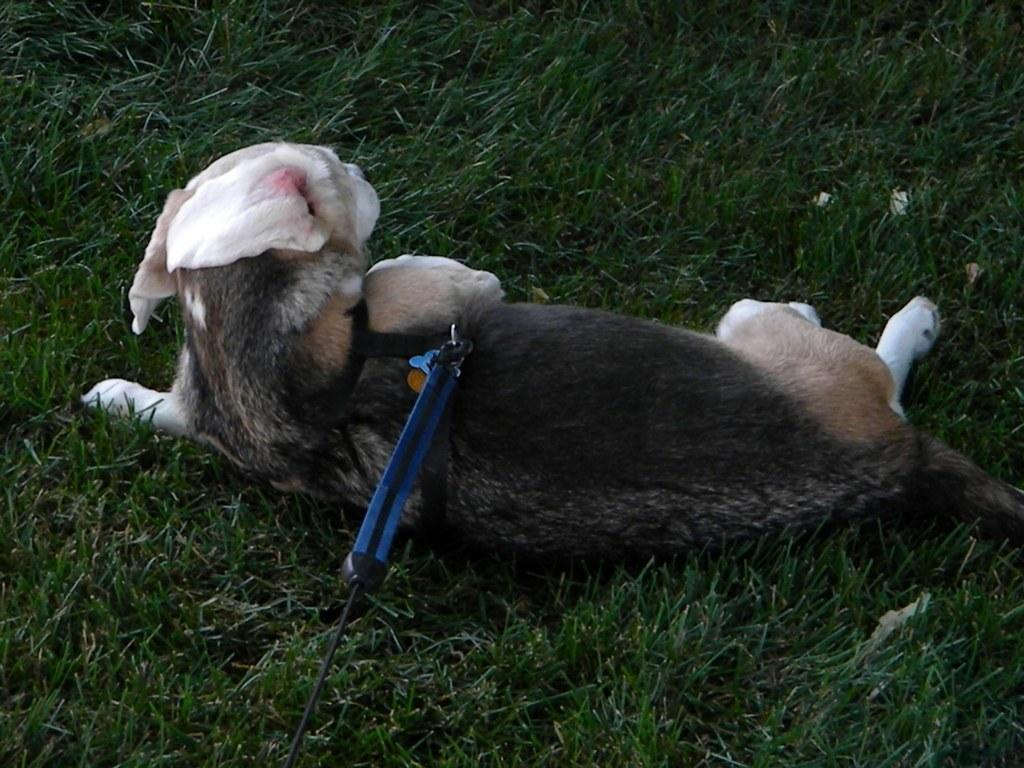What animal is present in the image? There is a dog in the image. Where is the dog located? The dog is sitting on the grass. What accessory is visible in the image? There is a dog belt visible in the image. How is the dog belt related to the dog? The dog belt is tied to the dog. What type of rhythm can be heard coming from the sofa in the image? There is no sofa present in the image, and therefore no rhythm can be heard from it. 